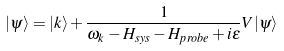Convert formula to latex. <formula><loc_0><loc_0><loc_500><loc_500>| \psi \rangle = | k \rangle + \frac { 1 } { \omega _ { k } - H _ { s y s } - H _ { p r o b e } + i \epsilon } V | \psi \rangle</formula> 